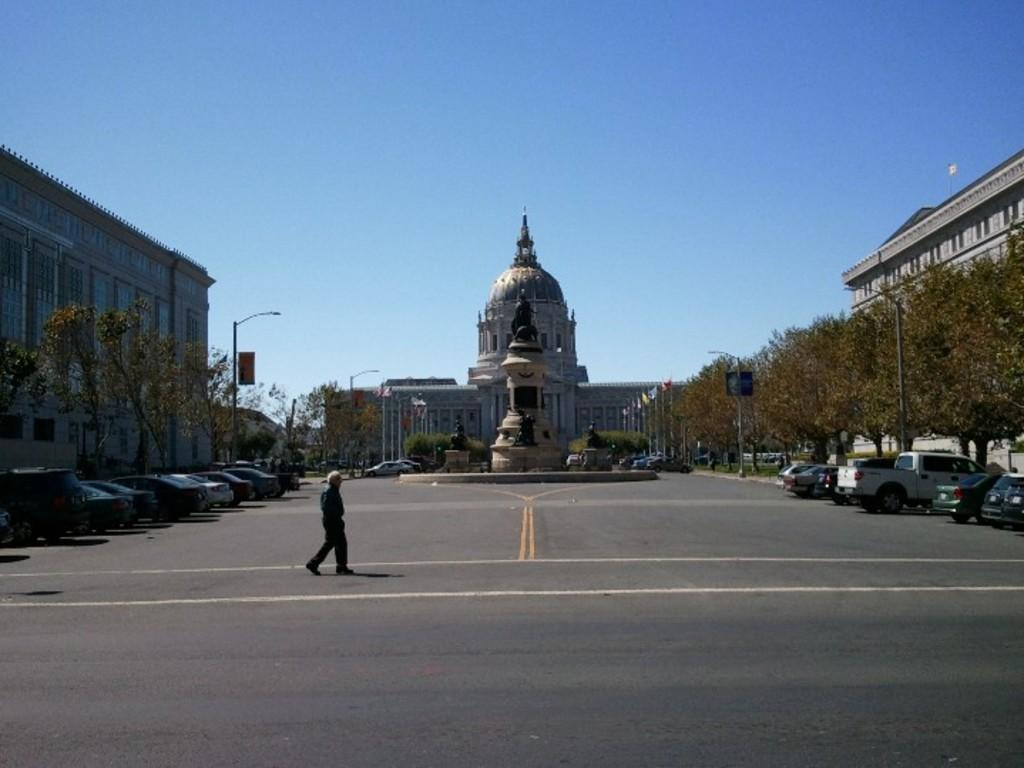What is the main subject of the image? There is a man in the image. What is the man doing in the image? The man is walking. What can be seen in the background of the image? There are cars, vehicles, trees, buildings, statues, a fountain, street lights, poles, flags, and the sky visible in the background of the image. What type of surface is the man walking on? The man is walking on a road, which can be seen in the background of the image. What type of bubble can be seen floating near the man in the image? There is no bubble present in the image. Who is the father of the man in the image? The facts provided do not mention any information about the man's father, so it cannot be determined from the image. 